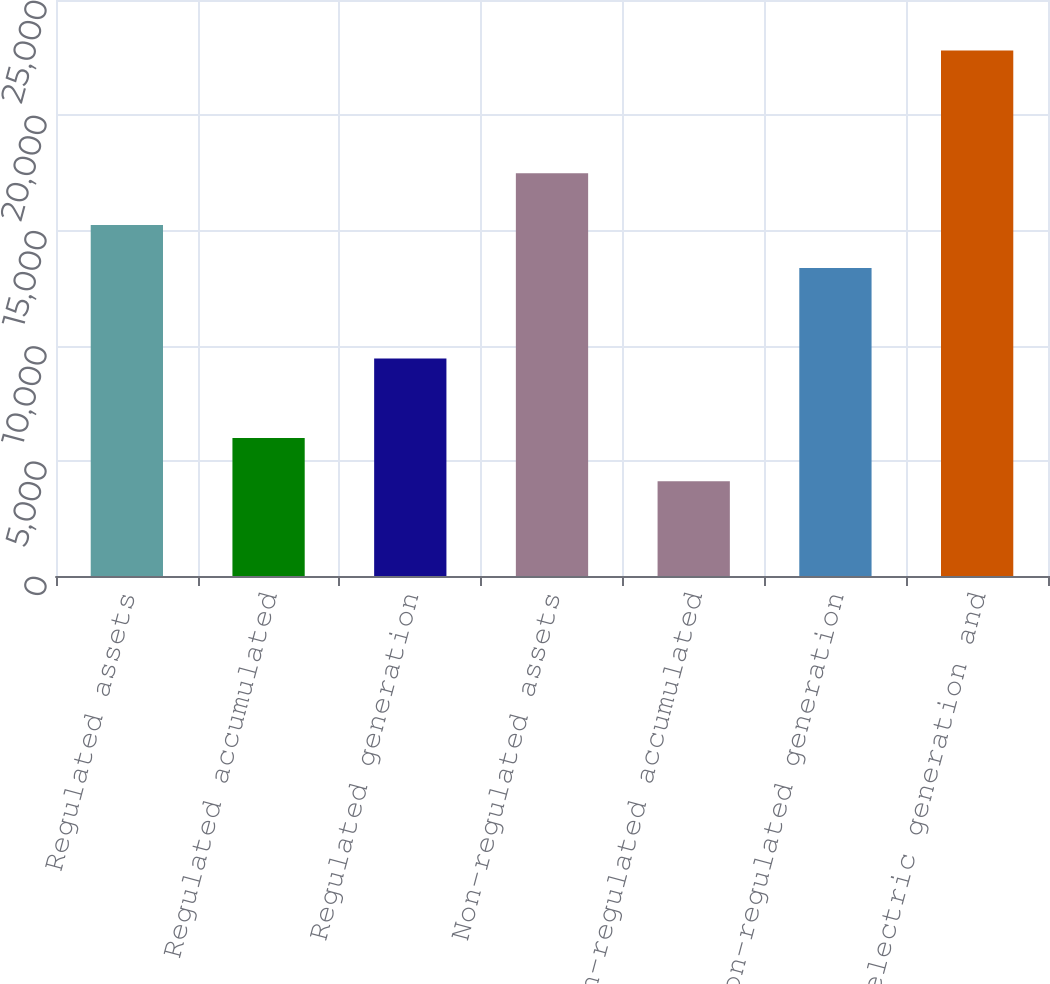Convert chart to OTSL. <chart><loc_0><loc_0><loc_500><loc_500><bar_chart><fcel>Regulated assets<fcel>Regulated accumulated<fcel>Regulated generation<fcel>Non-regulated assets<fcel>Non-regulated accumulated<fcel>Non-regulated generation<fcel>Net electric generation and<nl><fcel>15232.7<fcel>5984.7<fcel>9439<fcel>17480<fcel>4116<fcel>13364<fcel>22803<nl></chart> 